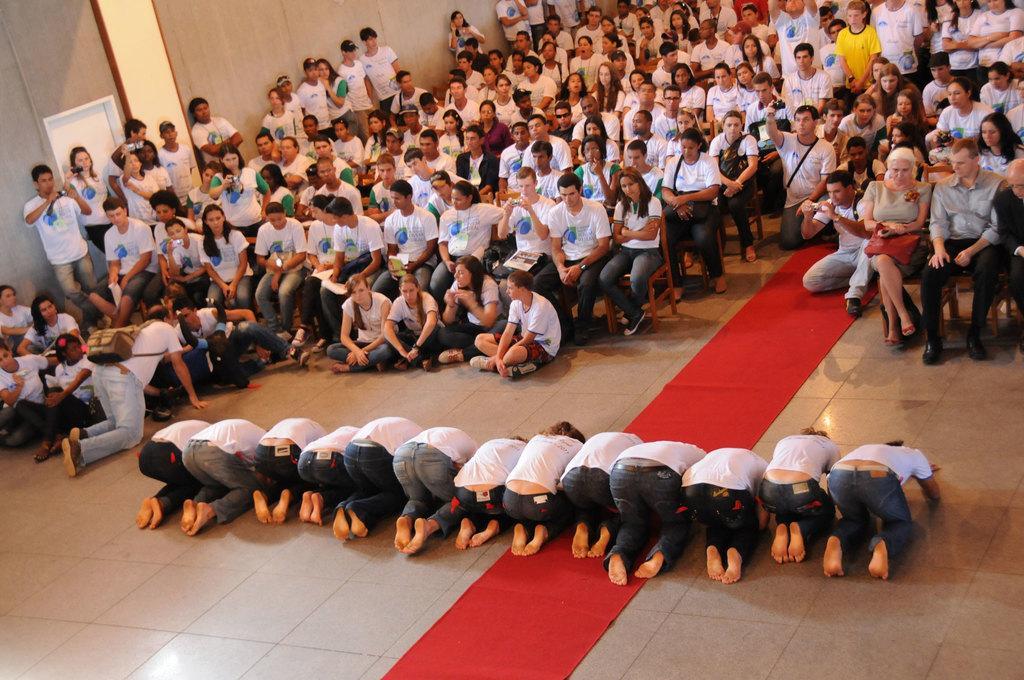How would you summarize this image in a sentence or two? The picture is taken in a hall. In the foreground of the picture there are people bowing and a red carpet. At the top there are people, many are sitting in chairs, few are standing and few are sitting on the floor. Towards left, at the top it is well. 